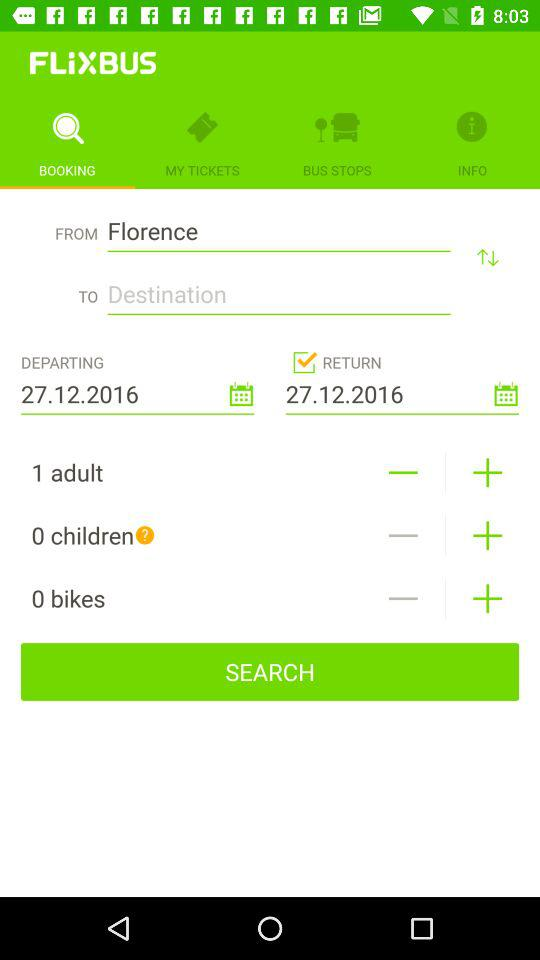How many adults are shown here? There is 1 adult shown here. 